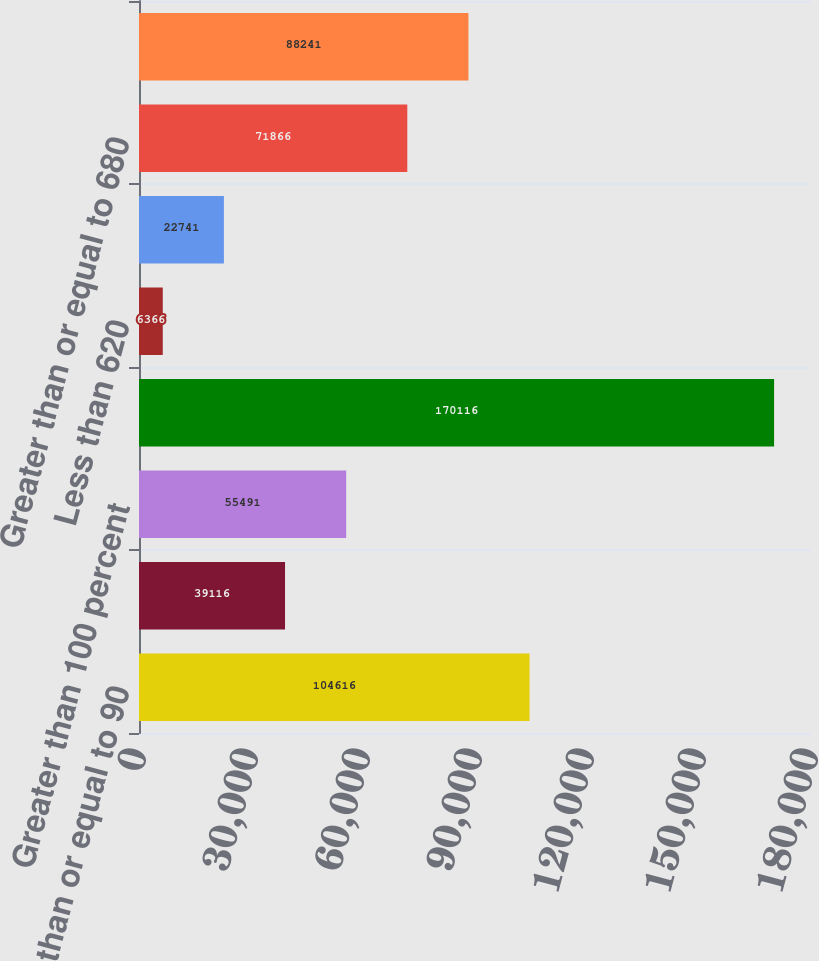Convert chart. <chart><loc_0><loc_0><loc_500><loc_500><bar_chart><fcel>Less than or equal to 90<fcel>Greater than 90 percent but<fcel>Greater than 100 percent<fcel>Total home loans<fcel>Less than 620<fcel>Greater than or equal to 620<fcel>Greater than or equal to 680<fcel>Greater than or equal to 740<nl><fcel>104616<fcel>39116<fcel>55491<fcel>170116<fcel>6366<fcel>22741<fcel>71866<fcel>88241<nl></chart> 